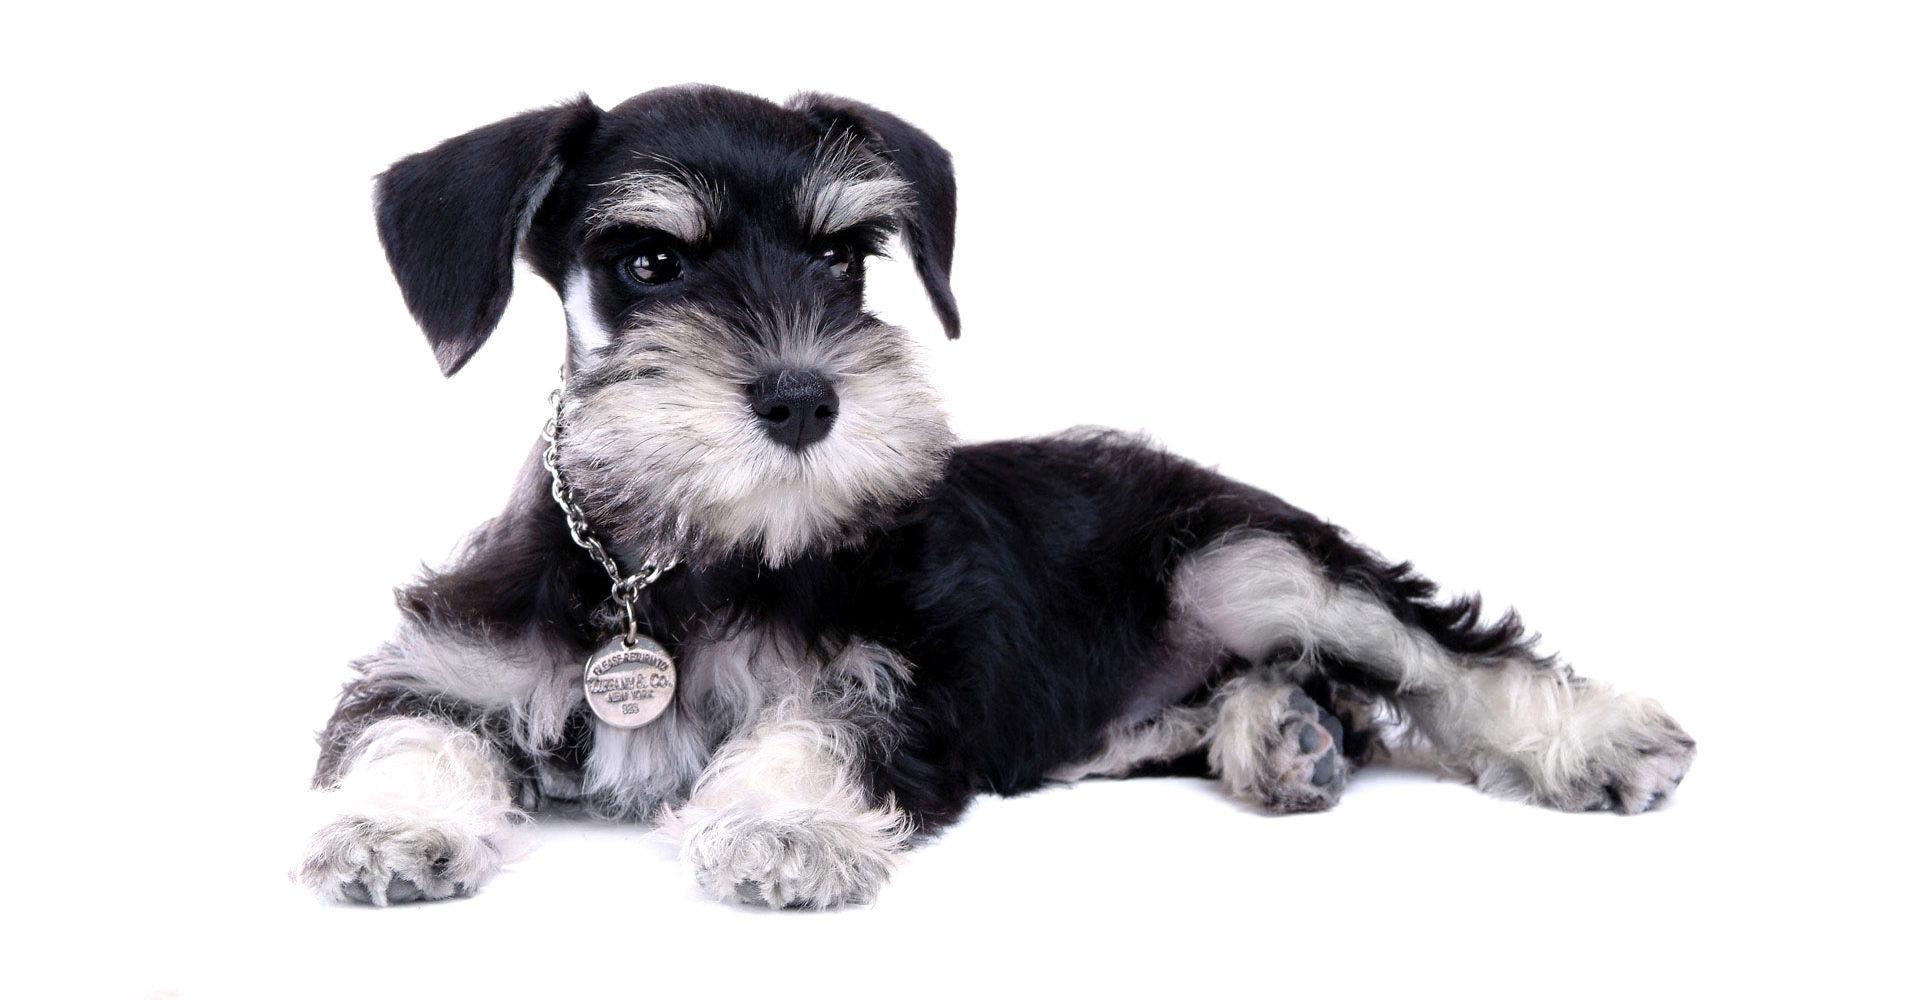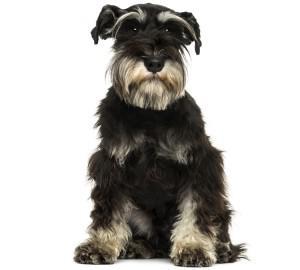The first image is the image on the left, the second image is the image on the right. Considering the images on both sides, is "There are two dogs, both lying down." valid? Answer yes or no. No. 